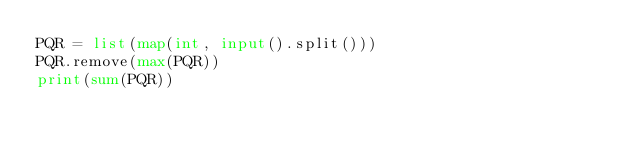Convert code to text. <code><loc_0><loc_0><loc_500><loc_500><_Python_>PQR = list(map(int, input().split()))
PQR.remove(max(PQR))
print(sum(PQR))</code> 